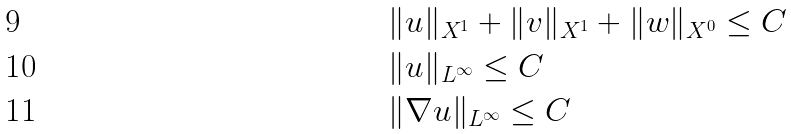<formula> <loc_0><loc_0><loc_500><loc_500>& \| u \| _ { X ^ { 1 } } + \| v \| _ { X ^ { 1 } } + \| w \| _ { X ^ { 0 } } \leq C \\ & \| u \| _ { L ^ { \infty } } \leq C \\ & \| \nabla u \| _ { L ^ { \infty } } \leq C</formula> 